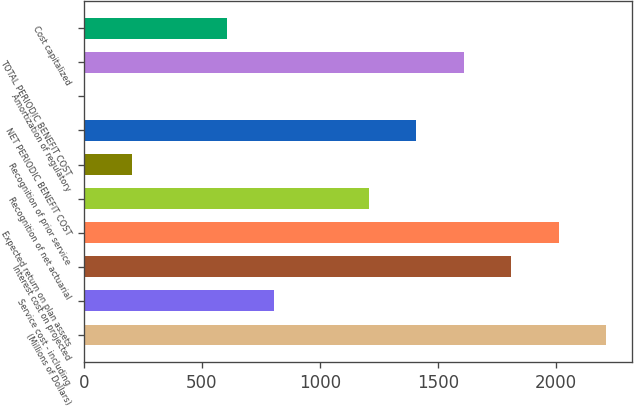<chart> <loc_0><loc_0><loc_500><loc_500><bar_chart><fcel>(Millions of Dollars)<fcel>Service cost - including<fcel>Interest cost on projected<fcel>Expected return on plan assets<fcel>Recognition of net actuarial<fcel>Recognition of prior service<fcel>NET PERIODIC BENEFIT COST<fcel>Amortization of regulatory<fcel>TOTAL PERIODIC BENEFIT COST<fcel>Cost capitalized<nl><fcel>2211.9<fcel>805.6<fcel>1810.1<fcel>2011<fcel>1207.4<fcel>202.9<fcel>1408.3<fcel>2<fcel>1609.2<fcel>604.7<nl></chart> 